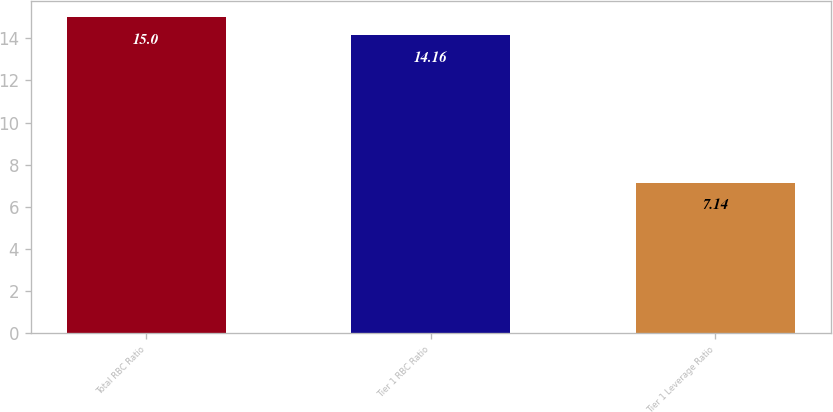<chart> <loc_0><loc_0><loc_500><loc_500><bar_chart><fcel>Total RBC Ratio<fcel>Tier 1 RBC Ratio<fcel>Tier 1 Leverage Ratio<nl><fcel>15<fcel>14.16<fcel>7.14<nl></chart> 